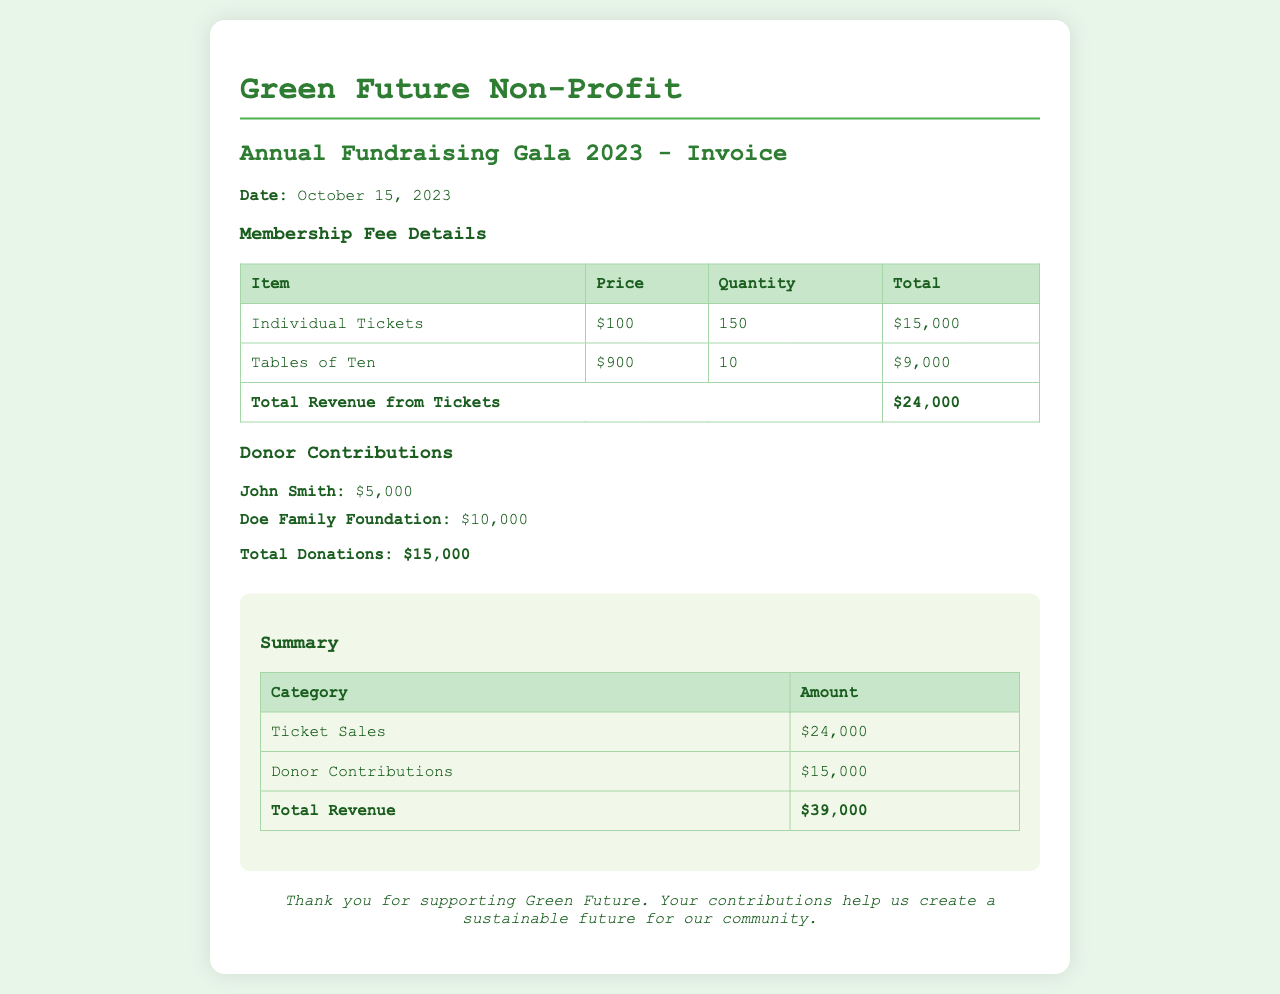what is the date of the invoice? The date of the invoice is explicitly stated in the document.
Answer: October 15, 2023 how many individual tickets were sold? The document provides the quantity of individual tickets listed under membership fee details.
Answer: 150 what is the total revenue from tickets? This total is calculated from the ticket sales section of the document, showing the summation of individual tickets and tables of ten sold.
Answer: $24,000 who is the donor that contributed $10,000? The document lists donors and their contributions in a specific section, making it easy to identify.
Answer: Doe Family Foundation what is the total amount of donations received? The total donations are summed from the individual contributions listed in the donor contributions section.
Answer: $15,000 what is the overall total revenue? The overall total revenue is derived from adding ticket sales and donor contributions detailed in the summary.
Answer: $39,000 how many tables of ten were bought? The quantity of tables of ten is provided in the membership fee details section of the document.
Answer: 10 what is the price per individual ticket? The price for an individual ticket is clearly mentioned in the membership fee details section.
Answer: $100 what category has the highest revenue? The document specifies revenues from different categories, allowing for a comparison to find the highest one.
Answer: Ticket Sales 